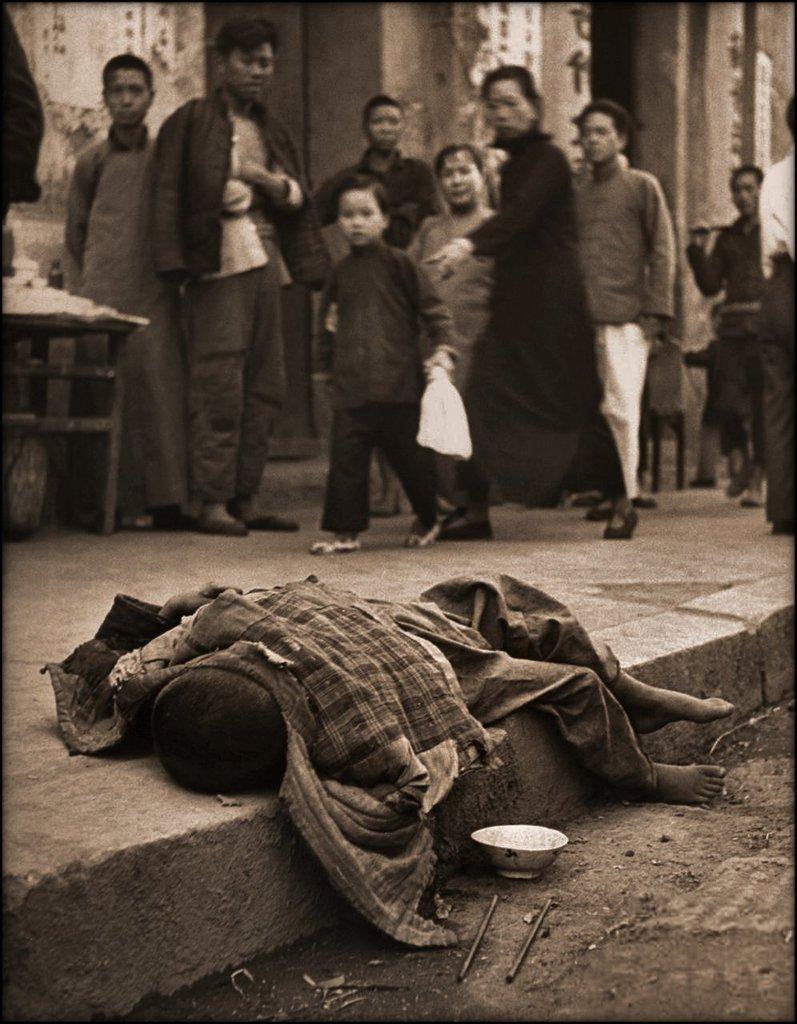Please provide a concise description of this image. In this image I can see a person sleeping on the floor. Background I can see few other persons standing and the person in front holding a cover and the image is in black and white. 